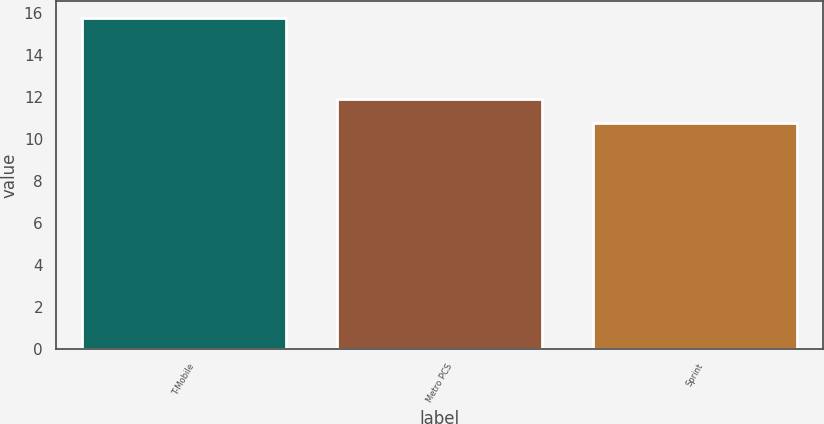Convert chart to OTSL. <chart><loc_0><loc_0><loc_500><loc_500><bar_chart><fcel>T-Mobile<fcel>Metro PCS<fcel>Sprint<nl><fcel>15.8<fcel>11.9<fcel>10.8<nl></chart> 